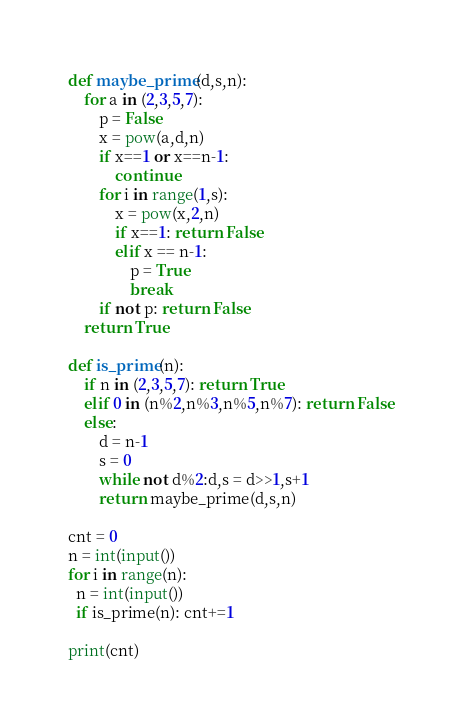Convert code to text. <code><loc_0><loc_0><loc_500><loc_500><_Python_>def maybe_prime(d,s,n):
    for a in (2,3,5,7):
        p = False
        x = pow(a,d,n)
        if x==1 or x==n-1:
            continue
        for i in range(1,s):
            x = pow(x,2,n)
            if x==1: return False
            elif x == n-1:
                p = True
                break
        if not p: return False
    return True

def is_prime(n):
    if n in (2,3,5,7): return True
    elif 0 in (n%2,n%3,n%5,n%7): return False
    else:
        d = n-1
        s = 0
        while not d%2:d,s = d>>1,s+1
        return maybe_prime(d,s,n)

cnt = 0
n = int(input())
for i in range(n):
  n = int(input())
  if is_prime(n): cnt+=1

print(cnt)</code> 